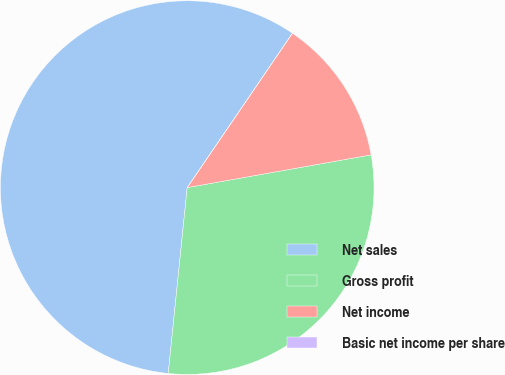Convert chart to OTSL. <chart><loc_0><loc_0><loc_500><loc_500><pie_chart><fcel>Net sales<fcel>Gross profit<fcel>Net income<fcel>Basic net income per share<nl><fcel>57.9%<fcel>29.42%<fcel>12.67%<fcel>0.0%<nl></chart> 